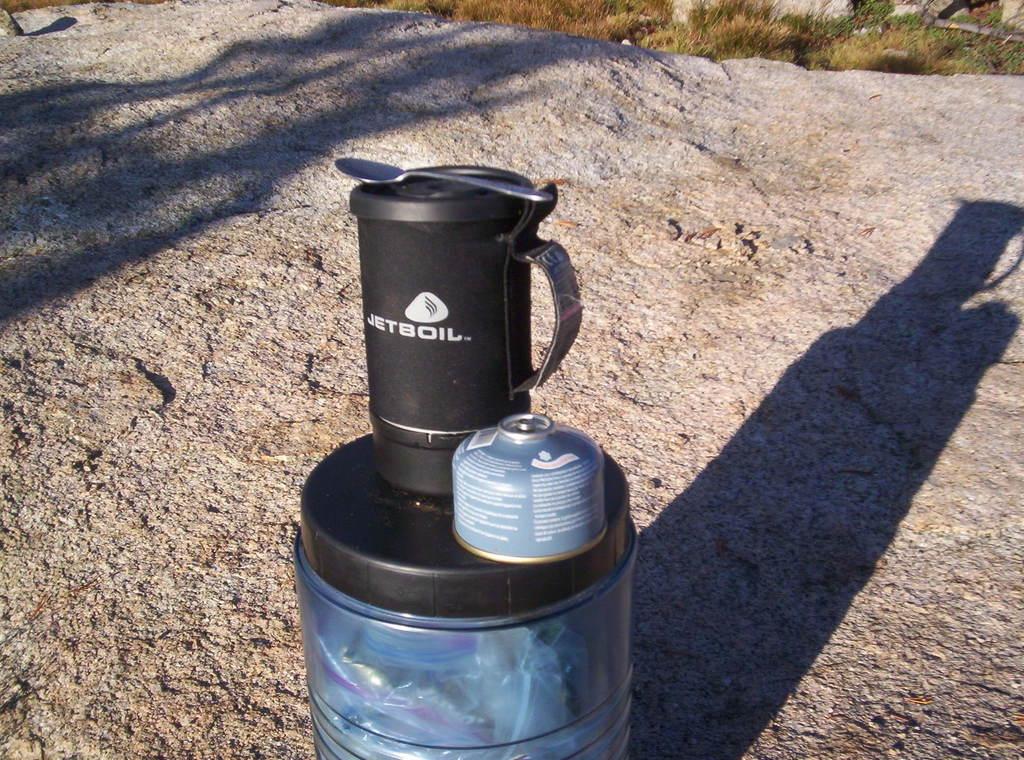What brand is this?
Keep it short and to the point. Jetboil. 